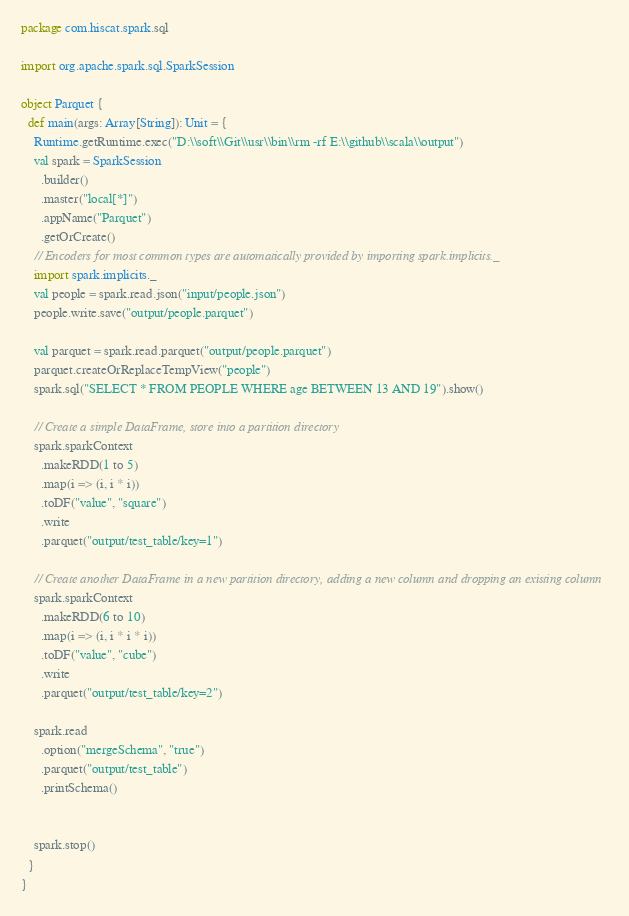Convert code to text. <code><loc_0><loc_0><loc_500><loc_500><_Scala_>package com.hiscat.spark.sql

import org.apache.spark.sql.SparkSession

object Parquet {
  def main(args: Array[String]): Unit = {
    Runtime.getRuntime.exec("D:\\soft\\Git\\usr\\bin\\rm -rf E:\\github\\scala\\output")
    val spark = SparkSession
      .builder()
      .master("local[*]")
      .appName("Parquet")
      .getOrCreate()
    // Encoders for most common types are automatically provided by importing spark.implicits._
    import spark.implicits._
    val people = spark.read.json("input/people.json")
    people.write.save("output/people.parquet")

    val parquet = spark.read.parquet("output/people.parquet")
    parquet.createOrReplaceTempView("people")
    spark.sql("SELECT * FROM PEOPLE WHERE age BETWEEN 13 AND 19").show()

    // Create a simple DataFrame, store into a partition directory
    spark.sparkContext
      .makeRDD(1 to 5)
      .map(i => (i, i * i))
      .toDF("value", "square")
      .write
      .parquet("output/test_table/key=1")

    // Create another DataFrame in a new partition directory, adding a new column and dropping an existing column
    spark.sparkContext
      .makeRDD(6 to 10)
      .map(i => (i, i * i * i))
      .toDF("value", "cube")
      .write
      .parquet("output/test_table/key=2")

    spark.read
      .option("mergeSchema", "true")
      .parquet("output/test_table")
      .printSchema()


    spark.stop()
  }
}
</code> 